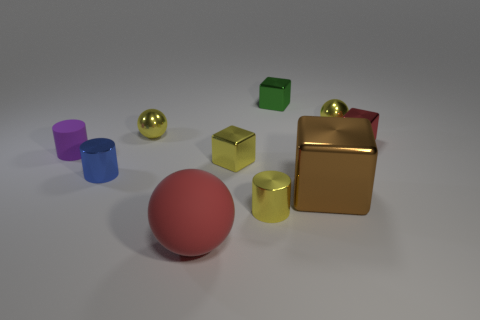Do the red ball and the blue metal cylinder have the same size?
Keep it short and to the point. No. Is the shape of the tiny purple thing the same as the tiny blue thing?
Offer a very short reply. Yes. Do the red rubber sphere in front of the blue metal cylinder and the yellow shiny sphere to the right of the large red matte object have the same size?
Keep it short and to the point. No. What size is the brown metal thing that is the same shape as the green metal object?
Ensure brevity in your answer.  Large. There is a big thing that is the same shape as the small green metallic thing; what is its color?
Your answer should be very brief. Brown. What color is the tiny cube left of the green shiny object on the right side of the rubber cylinder?
Keep it short and to the point. Yellow. What number of red objects are both left of the big metallic cube and behind the rubber sphere?
Keep it short and to the point. 0. Is the number of tiny purple rubber balls greater than the number of big metal blocks?
Provide a short and direct response. No. What material is the big sphere?
Provide a succinct answer. Rubber. There is a purple rubber thing to the left of the blue shiny object; what number of yellow cubes are in front of it?
Keep it short and to the point. 1. 